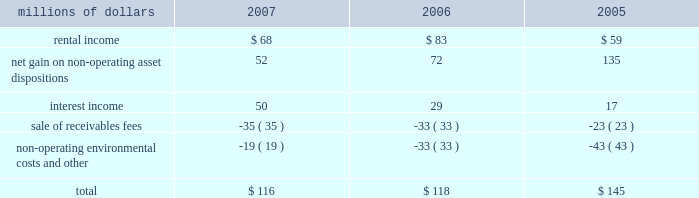Be resolved , we cannot reasonably determine the probability of an adverse claim or reasonably estimate any adverse liability or the total maximum exposure under these indemnification arrangements .
We do not have any reason to believe that we will be required to make any material payments under these indemnity provisions .
Income taxes 2013 as discussed in note 4 , the irs has completed its examinations and issued notices of deficiency for tax years 1995 through 2004 , and we are in different stages of the irs appeals process for these years .
The irs is examining our tax returns for tax years 2005 and 2006 .
In the third quarter of 2007 , we believe that we reached an agreement in principle with the irs to resolve all of the issues , except interest , related to tax years 1995 through 1998 , including the previously reported dispute over certain donations of property .
We anticipate signing a closing agreement in 2008 .
At december 31 , 2007 , we have recorded a current liability of $ 140 million for tax payments in 2008 related to federal and state income tax examinations .
We do not expect that the ultimate resolution of these examinations will have a material adverse effect on our consolidated financial statements .
11 .
Other income other income included the following for the years ended december 31 : millions of dollars 2007 2006 2005 .
12 .
Share repurchase program on january 30 , 2007 , our board of directors authorized the repurchase of up to 20 million shares of union pacific corporation common stock through the end of 2009 .
Management 2019s assessments of market conditions and other pertinent facts guide the timing and volume of all repurchases .
We expect to fund our common stock repurchases through cash generated from operations , the sale or lease of various operating and non- operating properties , debt issuances , and cash on hand at december 31 , 2007 .
During 2007 , we repurchased approximately 13 million shares under this program at an aggregate purchase price of approximately $ 1.5 billion .
These shares were recorded in treasury stock at cost , which includes any applicable commissions and fees. .
What percent of total other income was rental income in 2007? 
Computations: (68 / 116)
Answer: 0.58621. 